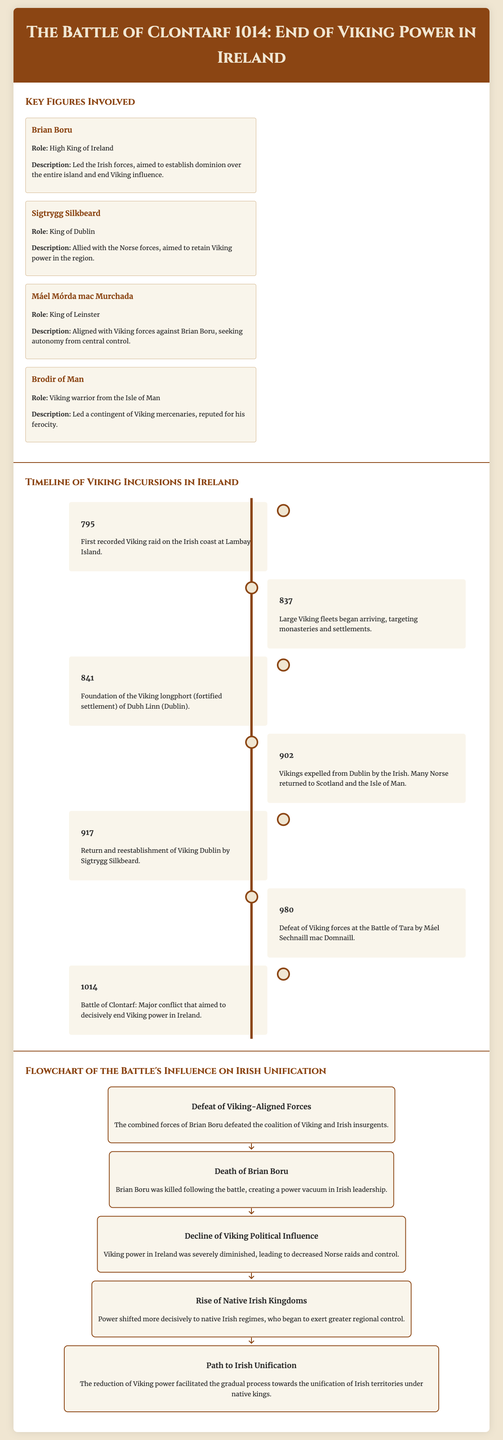What year did the Battle of Clontarf occur? The document lists the event of the Battle of Clontarf in the timeline, specifically stating it took place in the year 1014.
Answer: 1014 Who was the High King of Ireland during the battle? In the section on key figures, it is stated that Brian Boru held the title of High King of Ireland.
Answer: Brian Boru What was Sigtrygg Silkbeard's role? The document indicates that Sigtrygg Silkbeard served as the King of Dublin during the Battle of Clontarf.
Answer: King of Dublin What significant event happened in 841? According to the timeline, the year 841 marks the foundation of the Viking longphort of Dubh Linn (Dublin).
Answer: Foundation of the Viking longphort of Dubh Linn What was the outcome of the battle regarding Viking power? The flowchart illustrates that the battle led to a decline in Viking political influence in Ireland.
Answer: Decline of Viking political influence What did the defeat of Viking-aligned forces lead to? The flowchart specifies that the defeat led to the rise of native Irish kingdoms.
Answer: Rise of Native Irish Kingdoms In what year did Brian Boru die? The flowchart mentions the death of Brian Boru occurring after the Battle of Clontarf, but does not specify the year of his death; it implies it was shortly after 1014.
Answer: Not specified What was one of the consequences of Brian Boru's death? The flowchart notes that the death of Brian Boru created a power vacuum in Irish leadership.
Answer: Power vacuum in Irish leadership What did the battle facilitate in terms of Irish governance? The last item in the flowchart states that the reduction of Viking power facilitated the gradual process towards Irish unification.
Answer: Path to Irish Unification 